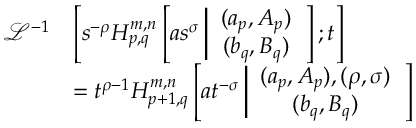<formula> <loc_0><loc_0><loc_500><loc_500>\begin{array} { r l } { \mathcal { L } ^ { - 1 } } & { \left [ s ^ { - \rho } H _ { p , q } ^ { m , n } \left [ a s ^ { \sigma } \left | \begin{array} { c } { ( a _ { p } , A _ { p } ) } \\ { ( b _ { q } , B _ { q } ) } \end{array} \right ] ; t \right ] } \\ & { = t ^ { \rho - 1 } H _ { p + 1 , q } ^ { m , n } \left [ a t ^ { - \sigma } \left | \begin{array} { c } { ( a _ { p } , A _ { p } ) , ( \rho , \sigma ) } \\ { ( b _ { q } , B _ { q } ) } \end{array} \right ] } \end{array}</formula> 